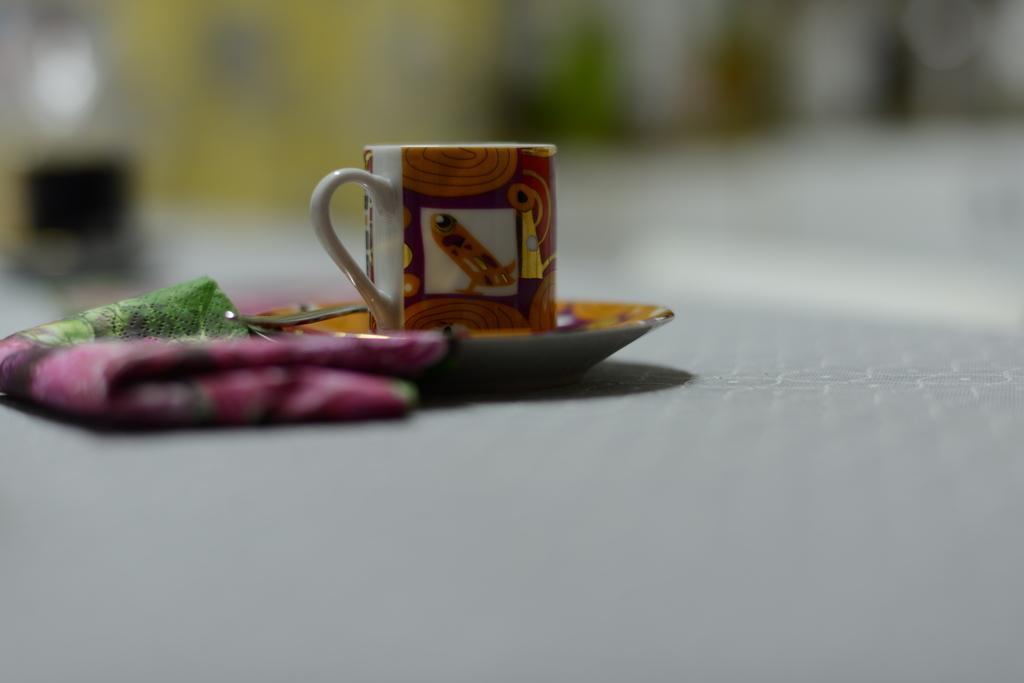Please provide a concise description of this image. Background of the picture is very blurry. Here we can see a cup, saucer and a cloth. 